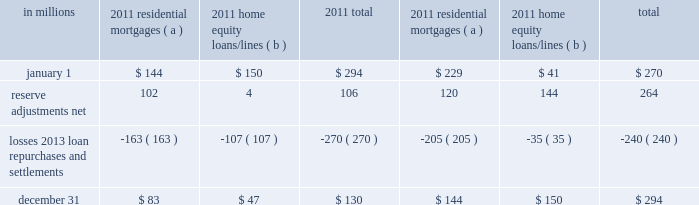Agreements associated with the agency securitizations , most sale agreements do not provide for penalties or other remedies if we do not respond timely to investor indemnification or repurchase requests .
Origination and sale of residential mortgages is an ongoing business activity and , accordingly , management continually assesses the need to recognize indemnification and repurchase liabilities pursuant to the associated investor sale agreements .
We establish indemnification and repurchase liabilities for estimated losses on sold first and second-lien mortgages and home equity loans/lines for which indemnification is expected to be provided or for loans that are expected to be repurchased .
For the first and second-lien mortgage sold portfolio , we have established an indemnification and repurchase liability pursuant to investor sale agreements based on claims made and our estimate of future claims on a loan by loan basis .
These relate primarily to loans originated during 2006-2008 .
For the home equity loans/lines sold portfolio , we have established indemnification and repurchase liabilities based upon this same methodology for loans sold during 2005-2007 .
Indemnification and repurchase liabilities are initially recognized when loans are sold to investors and are subsequently evaluated by management .
Initial recognition and subsequent adjustments to the indemnification and repurchase liability for the sold residential mortgage portfolio are recognized in residential mortgage revenue on the consolidated income statement .
Since pnc is no longer engaged in the brokered home equity lending business , only subsequent adjustments are recognized to the home equity loans/lines indemnification and repurchase liability .
These adjustments are recognized in other noninterest income on the consolidated income statement .
Management 2019s subsequent evaluation of these indemnification and repurchase liabilities is based upon trends in indemnification and repurchase requests , actual loss experience , risks in the underlying serviced loan portfolios , and current economic conditions .
As part of its evaluation , management considers estimated loss projections over the life of the subject loan portfolio .
At december 31 , 2011 and december 31 , 2010 , the total indemnification and repurchase liability for estimated losses on indemnification and repurchase claims totaled $ 130 million and $ 294 million , respectively , and was included in other liabilities on the consolidated balance sheet .
An analysis of the changes in this liability during 2011 and 2010 follows : analysis of indemnification and repurchase liability for asserted claims and unasserted claims .
( a ) repurchase obligation associated with sold loan portfolios of $ 121.4 billion and $ 139.8 billion at december 31 , 2011 and december 31 , 2010 , respectively .
( b ) repurchase obligation associated with sold loan portfolios of $ 4.5 billion and $ 6.5 billion at december 31 , 2011 and december 31 , 2010 , respectively .
Pnc is no longer engaged in the brokered home equity lending business , which was acquired with national city .
Management believes our indemnification and repurchase liabilities appropriately reflect the estimated probable losses on investor indemnification and repurchase claims at december 31 , 2011 and 2010 .
While management seeks to obtain all relevant information in estimating the indemnification and repurchase liability , the estimation process is inherently uncertain and imprecise and , accordingly , it is reasonably possible that future indemnification and repurchase losses could be more or less than our established liability .
Factors that could affect our estimate include the volume of valid claims driven by investor strategies and behavior , our ability to successfully negotiate claims with investors , housing prices , and other economic conditions .
At december 31 , 2011 , we estimate that it is reasonably possible that we could incur additional losses in excess of our indemnification and repurchase liability of up to $ 85 million .
This estimate of potential additional losses in excess of our liability is based on assumed higher investor demands , lower claim rescissions , and lower home prices than our current assumptions .
Reinsurance agreements we have two wholly-owned captive insurance subsidiaries which provide reinsurance to third-party insurers related to insurance sold to our customers .
These subsidiaries enter into various types of reinsurance agreements with third-party insurers where the subsidiary assumes the risk of loss through either an excess of loss or quota share agreement up to 100% ( 100 % ) reinsurance .
In excess of loss agreements , these subsidiaries assume the risk of loss for an excess layer of coverage up to specified limits , once a defined first loss percentage is met .
In quota share agreements , the subsidiaries and third-party insurers share the responsibility for payment of all claims .
These subsidiaries provide reinsurance for accidental death & dismemberment , credit life , accident & health , lender placed 200 the pnc financial services group , inc .
2013 form 10-k .
What was the ratio of the the total indemnification and repurchase liability for estimated losses on indemnification and repurchase claims \\n? 
Computations: (130 + 294)
Answer: 424.0. Agreements associated with the agency securitizations , most sale agreements do not provide for penalties or other remedies if we do not respond timely to investor indemnification or repurchase requests .
Origination and sale of residential mortgages is an ongoing business activity and , accordingly , management continually assesses the need to recognize indemnification and repurchase liabilities pursuant to the associated investor sale agreements .
We establish indemnification and repurchase liabilities for estimated losses on sold first and second-lien mortgages and home equity loans/lines for which indemnification is expected to be provided or for loans that are expected to be repurchased .
For the first and second-lien mortgage sold portfolio , we have established an indemnification and repurchase liability pursuant to investor sale agreements based on claims made and our estimate of future claims on a loan by loan basis .
These relate primarily to loans originated during 2006-2008 .
For the home equity loans/lines sold portfolio , we have established indemnification and repurchase liabilities based upon this same methodology for loans sold during 2005-2007 .
Indemnification and repurchase liabilities are initially recognized when loans are sold to investors and are subsequently evaluated by management .
Initial recognition and subsequent adjustments to the indemnification and repurchase liability for the sold residential mortgage portfolio are recognized in residential mortgage revenue on the consolidated income statement .
Since pnc is no longer engaged in the brokered home equity lending business , only subsequent adjustments are recognized to the home equity loans/lines indemnification and repurchase liability .
These adjustments are recognized in other noninterest income on the consolidated income statement .
Management 2019s subsequent evaluation of these indemnification and repurchase liabilities is based upon trends in indemnification and repurchase requests , actual loss experience , risks in the underlying serviced loan portfolios , and current economic conditions .
As part of its evaluation , management considers estimated loss projections over the life of the subject loan portfolio .
At december 31 , 2011 and december 31 , 2010 , the total indemnification and repurchase liability for estimated losses on indemnification and repurchase claims totaled $ 130 million and $ 294 million , respectively , and was included in other liabilities on the consolidated balance sheet .
An analysis of the changes in this liability during 2011 and 2010 follows : analysis of indemnification and repurchase liability for asserted claims and unasserted claims .
( a ) repurchase obligation associated with sold loan portfolios of $ 121.4 billion and $ 139.8 billion at december 31 , 2011 and december 31 , 2010 , respectively .
( b ) repurchase obligation associated with sold loan portfolios of $ 4.5 billion and $ 6.5 billion at december 31 , 2011 and december 31 , 2010 , respectively .
Pnc is no longer engaged in the brokered home equity lending business , which was acquired with national city .
Management believes our indemnification and repurchase liabilities appropriately reflect the estimated probable losses on investor indemnification and repurchase claims at december 31 , 2011 and 2010 .
While management seeks to obtain all relevant information in estimating the indemnification and repurchase liability , the estimation process is inherently uncertain and imprecise and , accordingly , it is reasonably possible that future indemnification and repurchase losses could be more or less than our established liability .
Factors that could affect our estimate include the volume of valid claims driven by investor strategies and behavior , our ability to successfully negotiate claims with investors , housing prices , and other economic conditions .
At december 31 , 2011 , we estimate that it is reasonably possible that we could incur additional losses in excess of our indemnification and repurchase liability of up to $ 85 million .
This estimate of potential additional losses in excess of our liability is based on assumed higher investor demands , lower claim rescissions , and lower home prices than our current assumptions .
Reinsurance agreements we have two wholly-owned captive insurance subsidiaries which provide reinsurance to third-party insurers related to insurance sold to our customers .
These subsidiaries enter into various types of reinsurance agreements with third-party insurers where the subsidiary assumes the risk of loss through either an excess of loss or quota share agreement up to 100% ( 100 % ) reinsurance .
In excess of loss agreements , these subsidiaries assume the risk of loss for an excess layer of coverage up to specified limits , once a defined first loss percentage is met .
In quota share agreements , the subsidiaries and third-party insurers share the responsibility for payment of all claims .
These subsidiaries provide reinsurance for accidental death & dismemberment , credit life , accident & health , lender placed 200 the pnc financial services group , inc .
2013 form 10-k .
In 2011 what was the percent of residential mortgages to the total liabilities at december 31? 
Computations: (83 / 130)
Answer: 0.63846. 